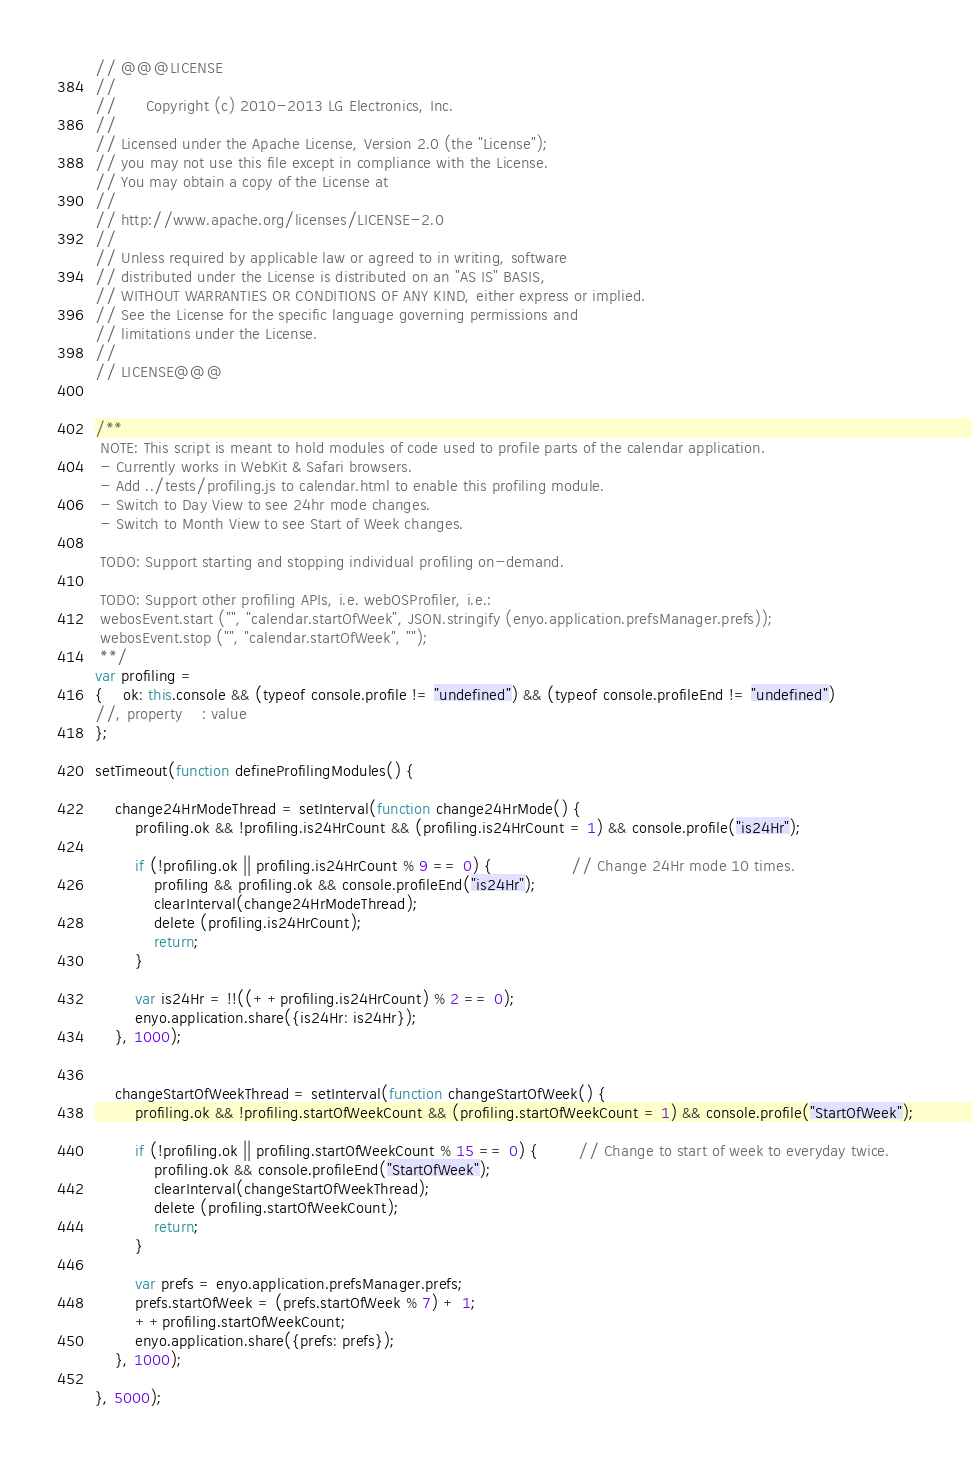<code> <loc_0><loc_0><loc_500><loc_500><_JavaScript_>// @@@LICENSE
//
//      Copyright (c) 2010-2013 LG Electronics, Inc.
//
// Licensed under the Apache License, Version 2.0 (the "License");
// you may not use this file except in compliance with the License.
// You may obtain a copy of the License at
//
// http://www.apache.org/licenses/LICENSE-2.0
//
// Unless required by applicable law or agreed to in writing, software
// distributed under the License is distributed on an "AS IS" BASIS,
// WITHOUT WARRANTIES OR CONDITIONS OF ANY KIND, either express or implied.
// See the License for the specific language governing permissions and
// limitations under the License.
//
// LICENSE@@@


/**
 NOTE: This script is meant to hold modules of code used to profile parts of the calendar application.
 - Currently works in WebKit & Safari browsers.
 - Add ../tests/profiling.js to calendar.html to enable this profiling module.
 - Switch to Day View to see 24hr mode changes.
 - Switch to Month View to see Start of Week changes.

 TODO: Support starting and stopping individual profiling on-demand.

 TODO: Support other profiling APIs, i.e. webOSProfiler, i.e.:
 webosEvent.start ("", "calendar.startOfWeek", JSON.stringify (enyo.application.prefsManager.prefs));
 webosEvent.stop ("", "calendar.startOfWeek", "");
 **/
var profiling =
{    ok: this.console && (typeof console.profile != "undefined") && (typeof console.profileEnd != "undefined")
//,	property	: value
};

setTimeout(function defineProfilingModules() {

    change24HrModeThread = setInterval(function change24HrMode() {
        profiling.ok && !profiling.is24HrCount && (profiling.is24HrCount = 1) && console.profile("is24Hr");

        if (!profiling.ok || profiling.is24HrCount % 9 == 0) {                // Change 24Hr mode 10 times.
            profiling && profiling.ok && console.profileEnd("is24Hr");
            clearInterval(change24HrModeThread);
            delete (profiling.is24HrCount);
            return;
        }

        var is24Hr = !!((++profiling.is24HrCount) % 2 == 0);
        enyo.application.share({is24Hr: is24Hr});
    }, 1000);


    changeStartOfWeekThread = setInterval(function changeStartOfWeek() {
        profiling.ok && !profiling.startOfWeekCount && (profiling.startOfWeekCount = 1) && console.profile("StartOfWeek");

        if (!profiling.ok || profiling.startOfWeekCount % 15 == 0) {        // Change to start of week to everyday twice.
            profiling.ok && console.profileEnd("StartOfWeek");
            clearInterval(changeStartOfWeekThread);
            delete (profiling.startOfWeekCount);
            return;
        }

        var prefs = enyo.application.prefsManager.prefs;
        prefs.startOfWeek = (prefs.startOfWeek % 7) + 1;
        ++profiling.startOfWeekCount;
        enyo.application.share({prefs: prefs});
    }, 1000);

}, 5000);
</code> 